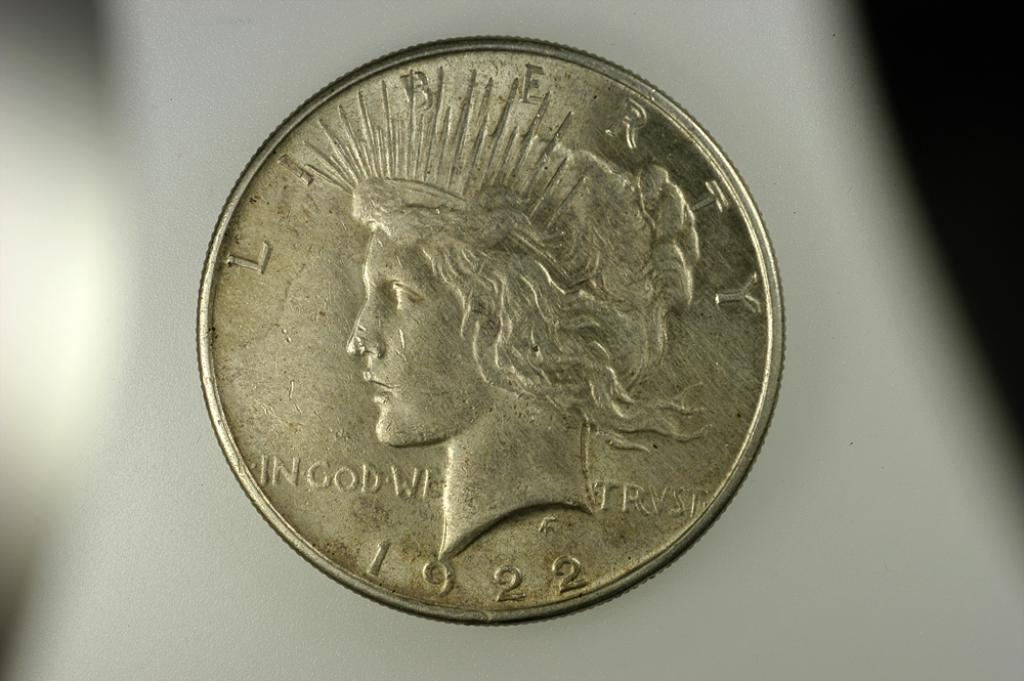What object can be seen in the image? There is a coin in the image. Who is present in the image? There is a woman in the image. How many eyes does the coin have in the image? Coins do not have eyes, as they are inanimate objects. 